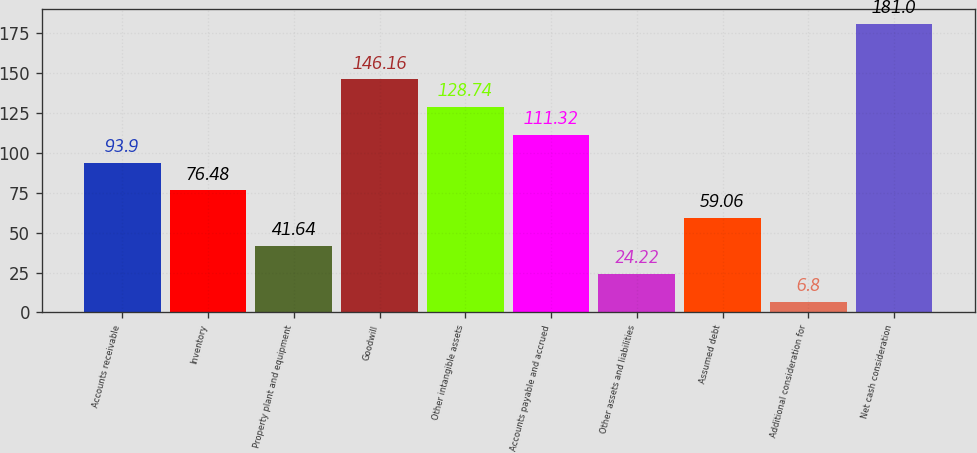Convert chart. <chart><loc_0><loc_0><loc_500><loc_500><bar_chart><fcel>Accounts receivable<fcel>Inventory<fcel>Property plant and equipment<fcel>Goodwill<fcel>Other intangible assets<fcel>Accounts payable and accrued<fcel>Other assets and liabilities<fcel>Assumed debt<fcel>Additional consideration for<fcel>Net cash consideration<nl><fcel>93.9<fcel>76.48<fcel>41.64<fcel>146.16<fcel>128.74<fcel>111.32<fcel>24.22<fcel>59.06<fcel>6.8<fcel>181<nl></chart> 